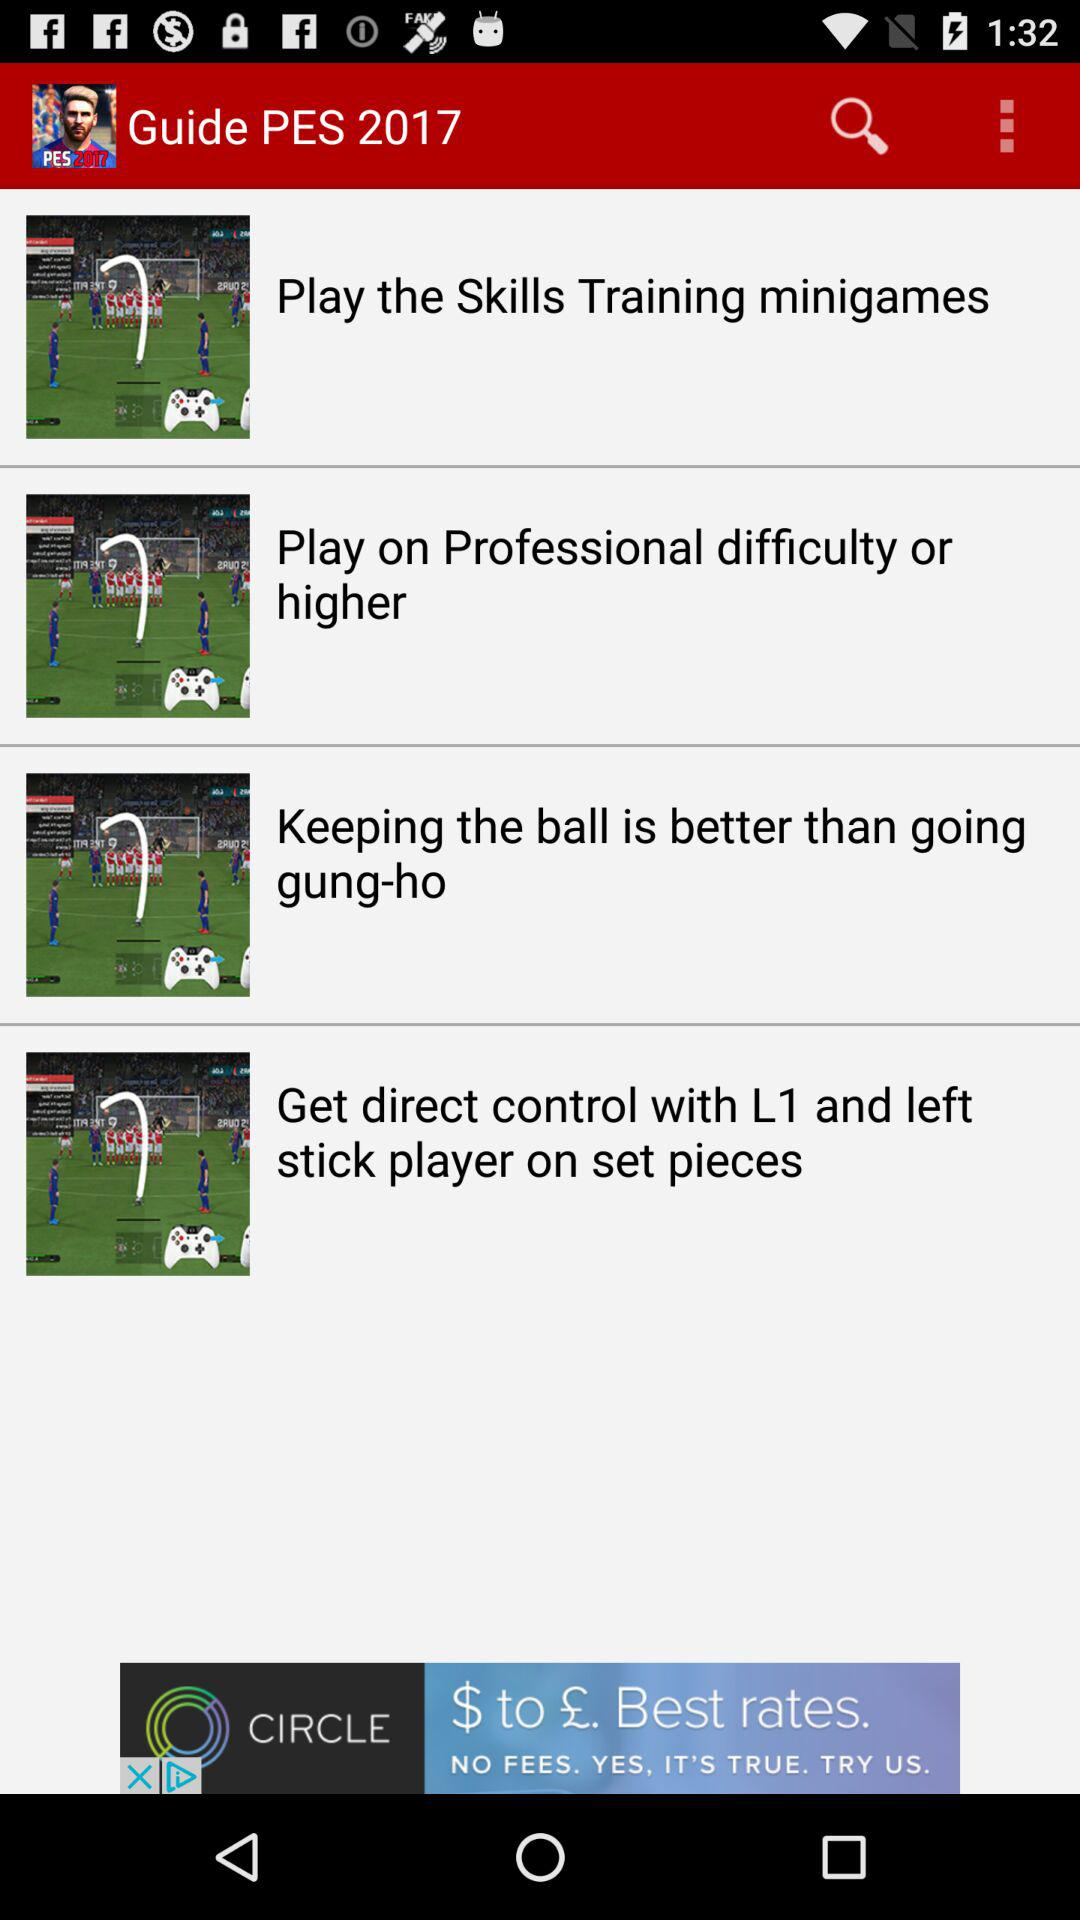What is the selected year? The selected year is 2017. 